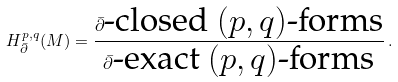Convert formula to latex. <formula><loc_0><loc_0><loc_500><loc_500>H ^ { p , q } _ { \bar { \partial } } ( M ) = \frac { \bar { \partial } \text {-closed $(p,q)$-forms} } { \bar { \partial } \text {-exact $(p,q)$-forms} } \, .</formula> 